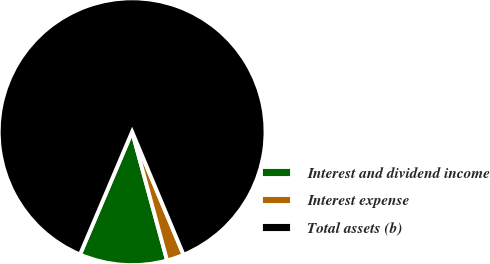Convert chart. <chart><loc_0><loc_0><loc_500><loc_500><pie_chart><fcel>Interest and dividend income<fcel>Interest expense<fcel>Total assets (b)<nl><fcel>10.61%<fcel>2.08%<fcel>87.31%<nl></chart> 